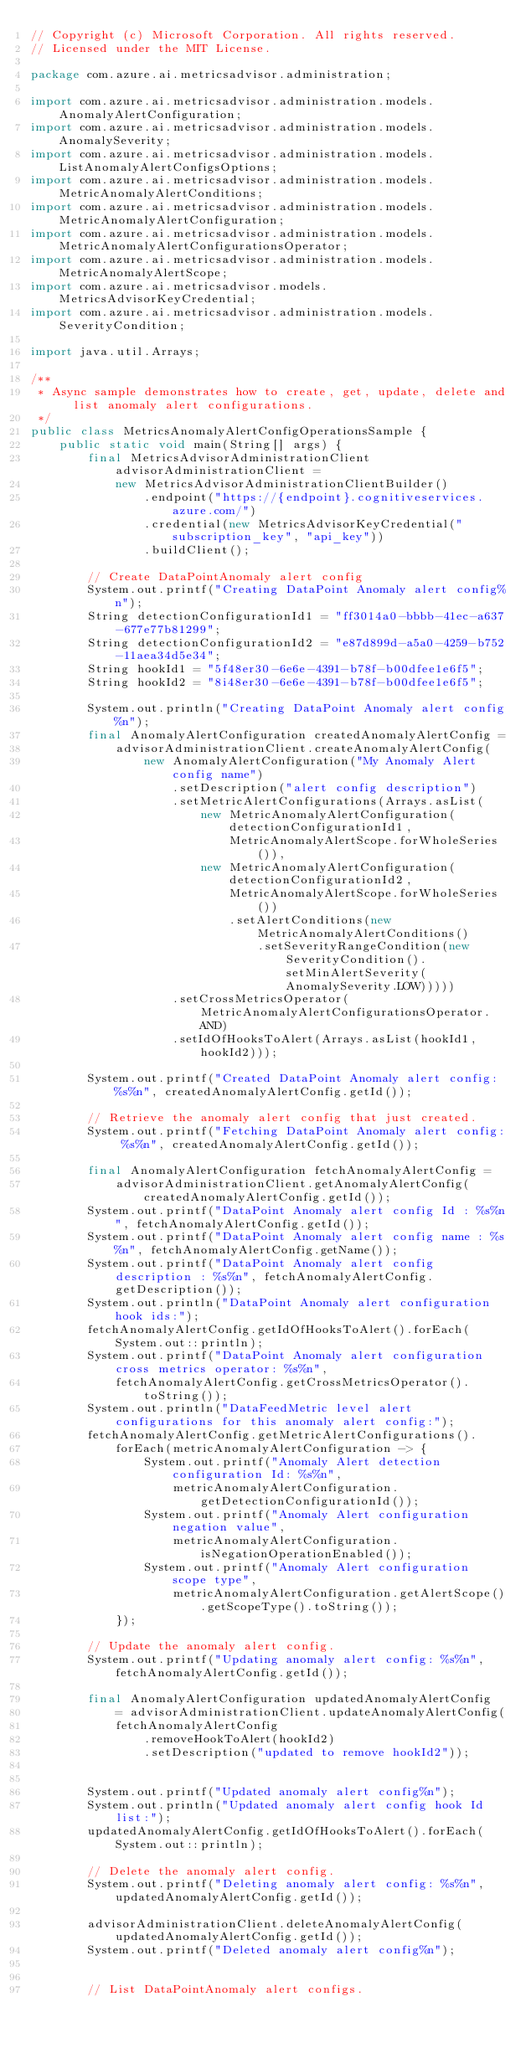<code> <loc_0><loc_0><loc_500><loc_500><_Java_>// Copyright (c) Microsoft Corporation. All rights reserved.
// Licensed under the MIT License.

package com.azure.ai.metricsadvisor.administration;

import com.azure.ai.metricsadvisor.administration.models.AnomalyAlertConfiguration;
import com.azure.ai.metricsadvisor.administration.models.AnomalySeverity;
import com.azure.ai.metricsadvisor.administration.models.ListAnomalyAlertConfigsOptions;
import com.azure.ai.metricsadvisor.administration.models.MetricAnomalyAlertConditions;
import com.azure.ai.metricsadvisor.administration.models.MetricAnomalyAlertConfiguration;
import com.azure.ai.metricsadvisor.administration.models.MetricAnomalyAlertConfigurationsOperator;
import com.azure.ai.metricsadvisor.administration.models.MetricAnomalyAlertScope;
import com.azure.ai.metricsadvisor.models.MetricsAdvisorKeyCredential;
import com.azure.ai.metricsadvisor.administration.models.SeverityCondition;

import java.util.Arrays;

/**
 * Async sample demonstrates how to create, get, update, delete and list anomaly alert configurations.
 */
public class MetricsAnomalyAlertConfigOperationsSample {
    public static void main(String[] args) {
        final MetricsAdvisorAdministrationClient advisorAdministrationClient =
            new MetricsAdvisorAdministrationClientBuilder()
                .endpoint("https://{endpoint}.cognitiveservices.azure.com/")
                .credential(new MetricsAdvisorKeyCredential("subscription_key", "api_key"))
                .buildClient();

        // Create DataPointAnomaly alert config
        System.out.printf("Creating DataPoint Anomaly alert config%n");
        String detectionConfigurationId1 = "ff3014a0-bbbb-41ec-a637-677e77b81299";
        String detectionConfigurationId2 = "e87d899d-a5a0-4259-b752-11aea34d5e34";
        String hookId1 = "5f48er30-6e6e-4391-b78f-b00dfee1e6f5";
        String hookId2 = "8i48er30-6e6e-4391-b78f-b00dfee1e6f5";

        System.out.println("Creating DataPoint Anomaly alert config%n");
        final AnomalyAlertConfiguration createdAnomalyAlertConfig =
            advisorAdministrationClient.createAnomalyAlertConfig(
                new AnomalyAlertConfiguration("My Anomaly Alert config name")
                    .setDescription("alert config description")
                    .setMetricAlertConfigurations(Arrays.asList(
                        new MetricAnomalyAlertConfiguration(detectionConfigurationId1,
                            MetricAnomalyAlertScope.forWholeSeries()),
                        new MetricAnomalyAlertConfiguration(detectionConfigurationId2,
                            MetricAnomalyAlertScope.forWholeSeries())
                            .setAlertConditions(new MetricAnomalyAlertConditions()
                                .setSeverityRangeCondition(new SeverityCondition().setMinAlertSeverity(AnomalySeverity.LOW)))))
                    .setCrossMetricsOperator(MetricAnomalyAlertConfigurationsOperator.AND)
                    .setIdOfHooksToAlert(Arrays.asList(hookId1, hookId2)));

        System.out.printf("Created DataPoint Anomaly alert config: %s%n", createdAnomalyAlertConfig.getId());

        // Retrieve the anomaly alert config that just created.
        System.out.printf("Fetching DataPoint Anomaly alert config: %s%n", createdAnomalyAlertConfig.getId());

        final AnomalyAlertConfiguration fetchAnomalyAlertConfig =
            advisorAdministrationClient.getAnomalyAlertConfig(createdAnomalyAlertConfig.getId());
        System.out.printf("DataPoint Anomaly alert config Id : %s%n", fetchAnomalyAlertConfig.getId());
        System.out.printf("DataPoint Anomaly alert config name : %s%n", fetchAnomalyAlertConfig.getName());
        System.out.printf("DataPoint Anomaly alert config description : %s%n", fetchAnomalyAlertConfig.getDescription());
        System.out.println("DataPoint Anomaly alert configuration hook ids:");
        fetchAnomalyAlertConfig.getIdOfHooksToAlert().forEach(System.out::println);
        System.out.printf("DataPoint Anomaly alert configuration cross metrics operator: %s%n",
            fetchAnomalyAlertConfig.getCrossMetricsOperator().toString());
        System.out.println("DataFeedMetric level alert configurations for this anomaly alert config:");
        fetchAnomalyAlertConfig.getMetricAlertConfigurations().
            forEach(metricAnomalyAlertConfiguration -> {
                System.out.printf("Anomaly Alert detection configuration Id: %s%n",
                    metricAnomalyAlertConfiguration.getDetectionConfigurationId());
                System.out.printf("Anomaly Alert configuration negation value",
                    metricAnomalyAlertConfiguration.isNegationOperationEnabled());
                System.out.printf("Anomaly Alert configuration scope type",
                    metricAnomalyAlertConfiguration.getAlertScope().getScopeType().toString());
            });

        // Update the anomaly alert config.
        System.out.printf("Updating anomaly alert config: %s%n", fetchAnomalyAlertConfig.getId());

        final AnomalyAlertConfiguration updatedAnomalyAlertConfig
            = advisorAdministrationClient.updateAnomalyAlertConfig(
            fetchAnomalyAlertConfig
                .removeHookToAlert(hookId2)
                .setDescription("updated to remove hookId2"));


        System.out.printf("Updated anomaly alert config%n");
        System.out.println("Updated anomaly alert config hook Id list:");
        updatedAnomalyAlertConfig.getIdOfHooksToAlert().forEach(System.out::println);

        // Delete the anomaly alert config.
        System.out.printf("Deleting anomaly alert config: %s%n", updatedAnomalyAlertConfig.getId());

        advisorAdministrationClient.deleteAnomalyAlertConfig(updatedAnomalyAlertConfig.getId());
        System.out.printf("Deleted anomaly alert config%n");


        // List DataPointAnomaly alert configs.</code> 